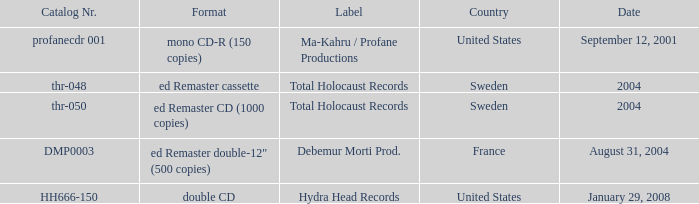In which country is the format ed remaster double-12" (500 copies) available? France. I'm looking to parse the entire table for insights. Could you assist me with that? {'header': ['Catalog Nr.', 'Format', 'Label', 'Country', 'Date'], 'rows': [['profanecdr 001', 'mono CD-R (150 copies)', 'Ma-Kahru / Profane Productions', 'United States', 'September 12, 2001'], ['thr-048', 'ed Remaster cassette', 'Total Holocaust Records', 'Sweden', '2004'], ['thr-050', 'ed Remaster CD (1000 copies)', 'Total Holocaust Records', 'Sweden', '2004'], ['DMP0003', 'ed Remaster double-12" (500 copies)', 'Debemur Morti Prod.', 'France', 'August 31, 2004'], ['HH666-150', 'double CD', 'Hydra Head Records', 'United States', 'January 29, 2008']]} 